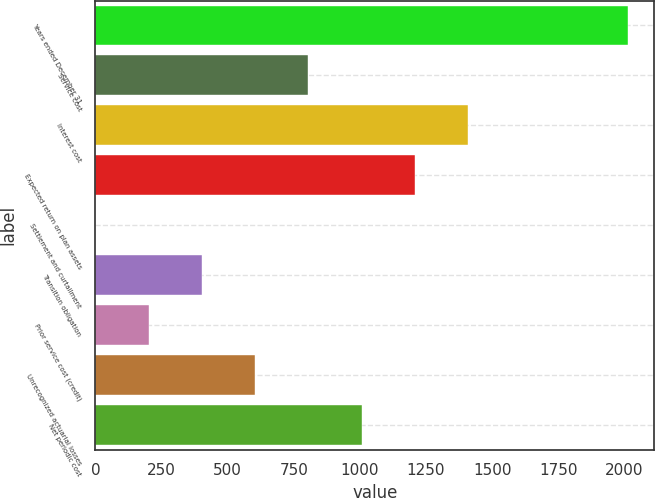<chart> <loc_0><loc_0><loc_500><loc_500><bar_chart><fcel>Years ended December 31<fcel>Service cost<fcel>Interest cost<fcel>Expected return on plan assets<fcel>Settlement and curtailment<fcel>Transition obligation<fcel>Prior service cost (credit)<fcel>Unrecognized actuarial losses<fcel>Net periodic cost<nl><fcel>2013<fcel>805.26<fcel>1409.13<fcel>1207.84<fcel>0.1<fcel>402.68<fcel>201.39<fcel>603.97<fcel>1006.55<nl></chart> 